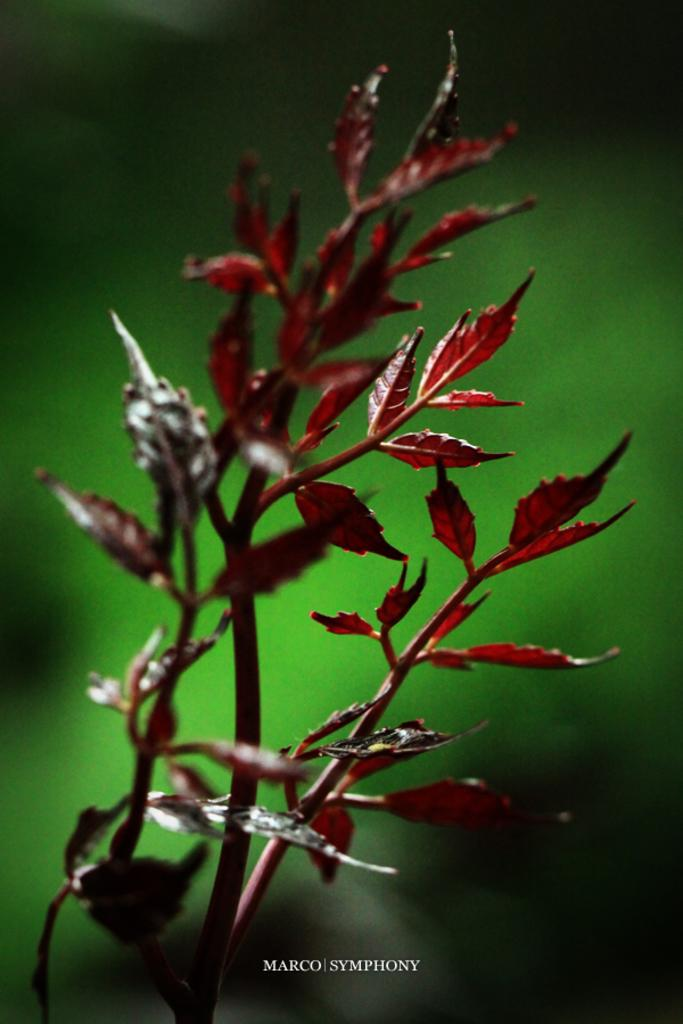What is the main subject in the center of the image? There is a plant in the center of the image. Where is the mom sitting on her throne in the image? There is no mom or throne present in the image; it only features a plant. 